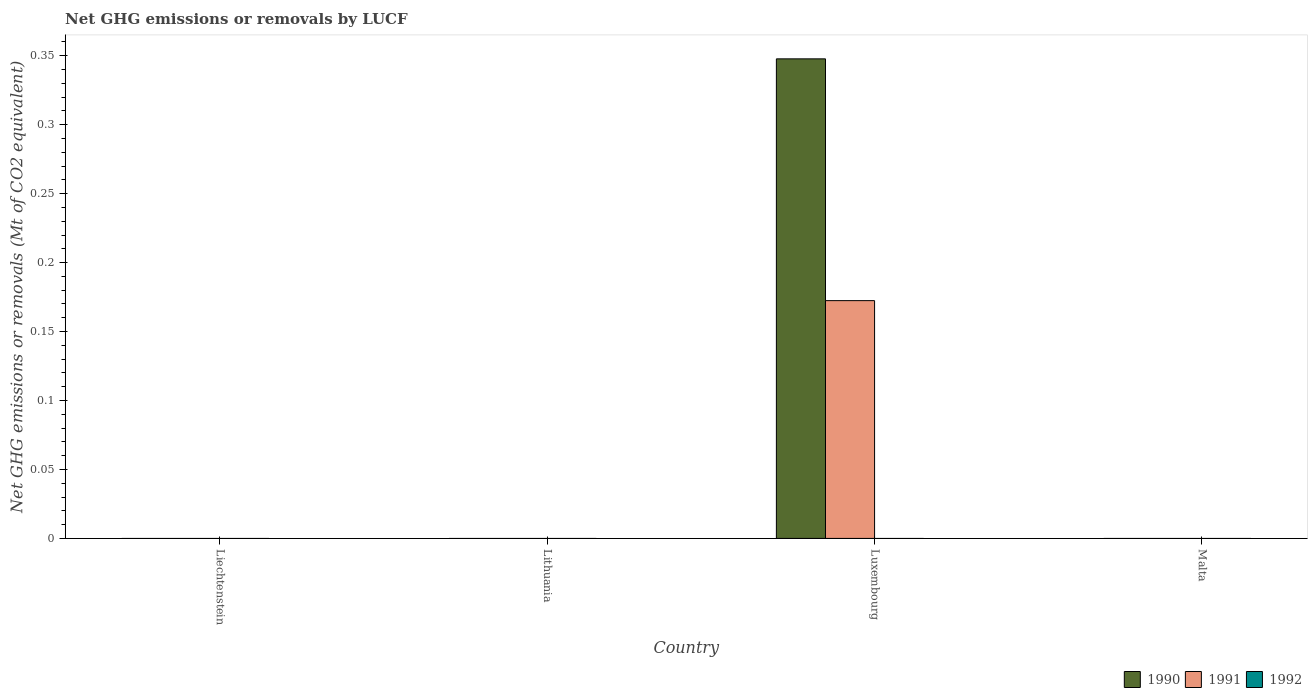How many different coloured bars are there?
Your response must be concise. 2. Are the number of bars per tick equal to the number of legend labels?
Offer a very short reply. No. Are the number of bars on each tick of the X-axis equal?
Make the answer very short. No. How many bars are there on the 2nd tick from the left?
Provide a succinct answer. 0. How many bars are there on the 2nd tick from the right?
Ensure brevity in your answer.  2. What is the label of the 1st group of bars from the left?
Your answer should be very brief. Liechtenstein. In how many cases, is the number of bars for a given country not equal to the number of legend labels?
Keep it short and to the point. 4. Across all countries, what is the maximum net GHG emissions or removals by LUCF in 1990?
Offer a terse response. 0.35. In which country was the net GHG emissions or removals by LUCF in 1990 maximum?
Your answer should be compact. Luxembourg. What is the total net GHG emissions or removals by LUCF in 1990 in the graph?
Offer a very short reply. 0.35. What is the average net GHG emissions or removals by LUCF in 1990 per country?
Offer a very short reply. 0.09. What is the difference between the net GHG emissions or removals by LUCF of/in 1990 and net GHG emissions or removals by LUCF of/in 1991 in Luxembourg?
Your response must be concise. 0.18. In how many countries, is the net GHG emissions or removals by LUCF in 1992 greater than 0.31000000000000005 Mt?
Give a very brief answer. 0. What is the difference between the highest and the lowest net GHG emissions or removals by LUCF in 1990?
Offer a terse response. 0.35. In how many countries, is the net GHG emissions or removals by LUCF in 1992 greater than the average net GHG emissions or removals by LUCF in 1992 taken over all countries?
Your response must be concise. 0. Is it the case that in every country, the sum of the net GHG emissions or removals by LUCF in 1991 and net GHG emissions or removals by LUCF in 1992 is greater than the net GHG emissions or removals by LUCF in 1990?
Your answer should be very brief. No. What is the difference between two consecutive major ticks on the Y-axis?
Your response must be concise. 0.05. Are the values on the major ticks of Y-axis written in scientific E-notation?
Offer a terse response. No. Does the graph contain grids?
Give a very brief answer. No. How are the legend labels stacked?
Ensure brevity in your answer.  Horizontal. What is the title of the graph?
Offer a terse response. Net GHG emissions or removals by LUCF. What is the label or title of the Y-axis?
Your answer should be compact. Net GHG emissions or removals (Mt of CO2 equivalent). What is the Net GHG emissions or removals (Mt of CO2 equivalent) of 1992 in Liechtenstein?
Provide a short and direct response. 0. What is the Net GHG emissions or removals (Mt of CO2 equivalent) in 1992 in Lithuania?
Make the answer very short. 0. What is the Net GHG emissions or removals (Mt of CO2 equivalent) in 1990 in Luxembourg?
Your answer should be compact. 0.35. What is the Net GHG emissions or removals (Mt of CO2 equivalent) in 1991 in Luxembourg?
Give a very brief answer. 0.17. Across all countries, what is the maximum Net GHG emissions or removals (Mt of CO2 equivalent) of 1990?
Provide a succinct answer. 0.35. Across all countries, what is the maximum Net GHG emissions or removals (Mt of CO2 equivalent) of 1991?
Your response must be concise. 0.17. What is the total Net GHG emissions or removals (Mt of CO2 equivalent) in 1990 in the graph?
Provide a short and direct response. 0.35. What is the total Net GHG emissions or removals (Mt of CO2 equivalent) in 1991 in the graph?
Your response must be concise. 0.17. What is the average Net GHG emissions or removals (Mt of CO2 equivalent) in 1990 per country?
Offer a very short reply. 0.09. What is the average Net GHG emissions or removals (Mt of CO2 equivalent) in 1991 per country?
Provide a succinct answer. 0.04. What is the difference between the Net GHG emissions or removals (Mt of CO2 equivalent) of 1990 and Net GHG emissions or removals (Mt of CO2 equivalent) of 1991 in Luxembourg?
Provide a short and direct response. 0.18. What is the difference between the highest and the lowest Net GHG emissions or removals (Mt of CO2 equivalent) of 1990?
Your response must be concise. 0.35. What is the difference between the highest and the lowest Net GHG emissions or removals (Mt of CO2 equivalent) of 1991?
Ensure brevity in your answer.  0.17. 